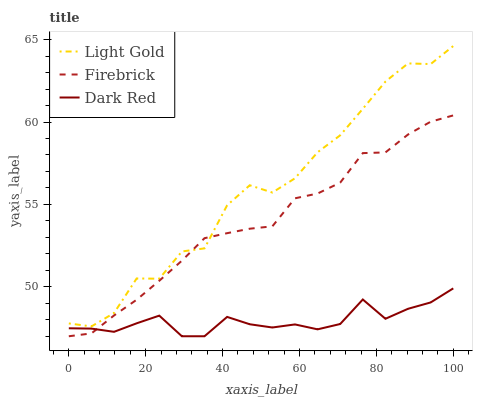Does Firebrick have the minimum area under the curve?
Answer yes or no. No. Does Firebrick have the maximum area under the curve?
Answer yes or no. No. Is Light Gold the smoothest?
Answer yes or no. No. Is Firebrick the roughest?
Answer yes or no. No. Does Light Gold have the lowest value?
Answer yes or no. No. Does Firebrick have the highest value?
Answer yes or no. No. Is Dark Red less than Light Gold?
Answer yes or no. Yes. Is Light Gold greater than Dark Red?
Answer yes or no. Yes. Does Dark Red intersect Light Gold?
Answer yes or no. No. 